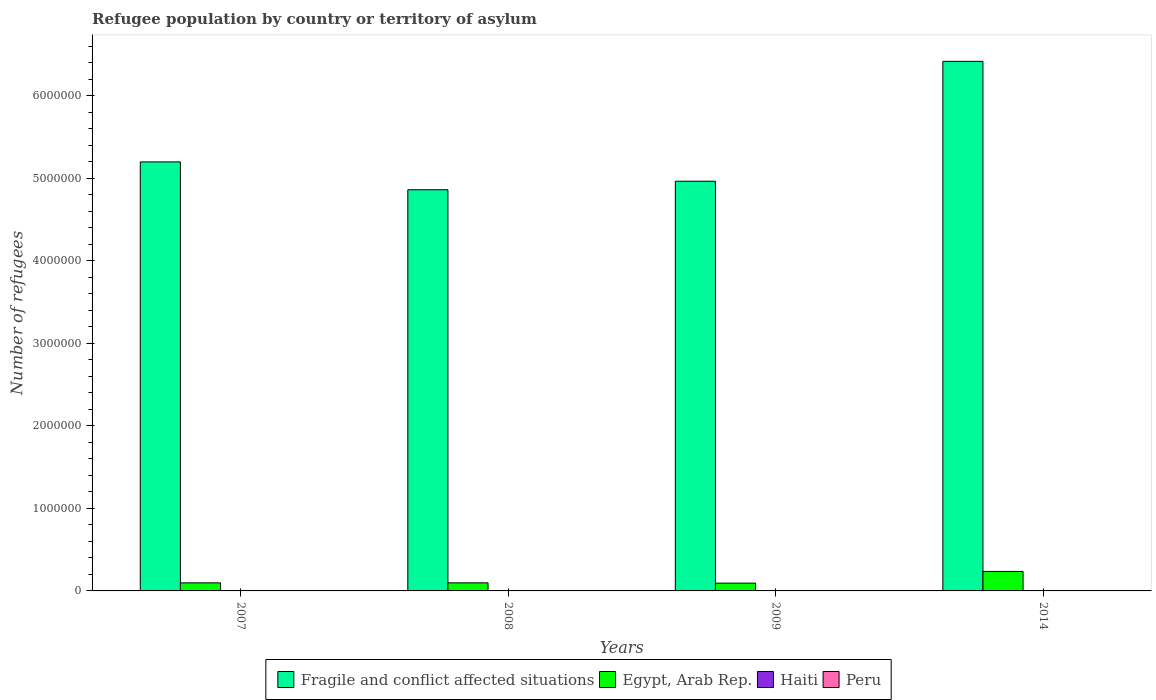How many different coloured bars are there?
Provide a short and direct response. 4. Are the number of bars per tick equal to the number of legend labels?
Make the answer very short. Yes. Are the number of bars on each tick of the X-axis equal?
Make the answer very short. Yes. How many bars are there on the 2nd tick from the left?
Provide a succinct answer. 4. In how many cases, is the number of bars for a given year not equal to the number of legend labels?
Keep it short and to the point. 0. What is the number of refugees in Peru in 2009?
Provide a short and direct response. 1108. Across all years, what is the maximum number of refugees in Egypt, Arab Rep.?
Give a very brief answer. 2.36e+05. Across all years, what is the minimum number of refugees in Fragile and conflict affected situations?
Your answer should be compact. 4.86e+06. In which year was the number of refugees in Egypt, Arab Rep. maximum?
Offer a terse response. 2014. In which year was the number of refugees in Haiti minimum?
Ensure brevity in your answer.  2007. What is the difference between the number of refugees in Egypt, Arab Rep. in 2008 and the number of refugees in Fragile and conflict affected situations in 2009?
Your answer should be compact. -4.87e+06. What is the average number of refugees in Egypt, Arab Rep. per year?
Your answer should be very brief. 1.31e+05. In the year 2014, what is the difference between the number of refugees in Fragile and conflict affected situations and number of refugees in Haiti?
Make the answer very short. 6.42e+06. What is the ratio of the number of refugees in Egypt, Arab Rep. in 2007 to that in 2009?
Offer a terse response. 1.03. What is the difference between the highest and the second highest number of refugees in Fragile and conflict affected situations?
Your answer should be compact. 1.22e+06. What is the difference between the highest and the lowest number of refugees in Egypt, Arab Rep.?
Make the answer very short. 1.42e+05. In how many years, is the number of refugees in Peru greater than the average number of refugees in Peru taken over all years?
Provide a succinct answer. 1. Is the sum of the number of refugees in Haiti in 2009 and 2014 greater than the maximum number of refugees in Fragile and conflict affected situations across all years?
Ensure brevity in your answer.  No. What does the 1st bar from the left in 2008 represents?
Give a very brief answer. Fragile and conflict affected situations. What does the 3rd bar from the right in 2008 represents?
Your answer should be very brief. Egypt, Arab Rep. How many bars are there?
Your answer should be very brief. 16. How many years are there in the graph?
Your answer should be very brief. 4. What is the difference between two consecutive major ticks on the Y-axis?
Your answer should be very brief. 1.00e+06. Are the values on the major ticks of Y-axis written in scientific E-notation?
Your answer should be very brief. No. Does the graph contain grids?
Give a very brief answer. No. Where does the legend appear in the graph?
Offer a very short reply. Bottom center. What is the title of the graph?
Your answer should be compact. Refugee population by country or territory of asylum. Does "South Africa" appear as one of the legend labels in the graph?
Provide a succinct answer. No. What is the label or title of the Y-axis?
Offer a terse response. Number of refugees. What is the Number of refugees of Fragile and conflict affected situations in 2007?
Provide a short and direct response. 5.20e+06. What is the Number of refugees of Egypt, Arab Rep. in 2007?
Your answer should be compact. 9.76e+04. What is the Number of refugees in Peru in 2007?
Offer a very short reply. 995. What is the Number of refugees of Fragile and conflict affected situations in 2008?
Give a very brief answer. 4.86e+06. What is the Number of refugees in Egypt, Arab Rep. in 2008?
Offer a terse response. 9.79e+04. What is the Number of refugees in Haiti in 2008?
Ensure brevity in your answer.  3. What is the Number of refugees of Peru in 2008?
Give a very brief answer. 1075. What is the Number of refugees in Fragile and conflict affected situations in 2009?
Your answer should be compact. 4.96e+06. What is the Number of refugees of Egypt, Arab Rep. in 2009?
Make the answer very short. 9.44e+04. What is the Number of refugees of Haiti in 2009?
Your answer should be compact. 3. What is the Number of refugees in Peru in 2009?
Make the answer very short. 1108. What is the Number of refugees in Fragile and conflict affected situations in 2014?
Keep it short and to the point. 6.42e+06. What is the Number of refugees in Egypt, Arab Rep. in 2014?
Your response must be concise. 2.36e+05. What is the Number of refugees of Peru in 2014?
Offer a very short reply. 1303. Across all years, what is the maximum Number of refugees in Fragile and conflict affected situations?
Your answer should be compact. 6.42e+06. Across all years, what is the maximum Number of refugees in Egypt, Arab Rep.?
Your response must be concise. 2.36e+05. Across all years, what is the maximum Number of refugees in Haiti?
Provide a short and direct response. 3. Across all years, what is the maximum Number of refugees of Peru?
Give a very brief answer. 1303. Across all years, what is the minimum Number of refugees of Fragile and conflict affected situations?
Your response must be concise. 4.86e+06. Across all years, what is the minimum Number of refugees in Egypt, Arab Rep.?
Provide a short and direct response. 9.44e+04. Across all years, what is the minimum Number of refugees of Peru?
Offer a terse response. 995. What is the total Number of refugees in Fragile and conflict affected situations in the graph?
Offer a terse response. 2.14e+07. What is the total Number of refugees of Egypt, Arab Rep. in the graph?
Offer a terse response. 5.26e+05. What is the total Number of refugees of Haiti in the graph?
Offer a terse response. 10. What is the total Number of refugees in Peru in the graph?
Your response must be concise. 4481. What is the difference between the Number of refugees of Fragile and conflict affected situations in 2007 and that in 2008?
Your answer should be very brief. 3.37e+05. What is the difference between the Number of refugees in Egypt, Arab Rep. in 2007 and that in 2008?
Offer a terse response. -305. What is the difference between the Number of refugees of Peru in 2007 and that in 2008?
Provide a succinct answer. -80. What is the difference between the Number of refugees in Fragile and conflict affected situations in 2007 and that in 2009?
Ensure brevity in your answer.  2.34e+05. What is the difference between the Number of refugees in Egypt, Arab Rep. in 2007 and that in 2009?
Offer a terse response. 3150. What is the difference between the Number of refugees in Peru in 2007 and that in 2009?
Give a very brief answer. -113. What is the difference between the Number of refugees in Fragile and conflict affected situations in 2007 and that in 2014?
Keep it short and to the point. -1.22e+06. What is the difference between the Number of refugees in Egypt, Arab Rep. in 2007 and that in 2014?
Keep it short and to the point. -1.39e+05. What is the difference between the Number of refugees in Haiti in 2007 and that in 2014?
Offer a terse response. -2. What is the difference between the Number of refugees in Peru in 2007 and that in 2014?
Offer a terse response. -308. What is the difference between the Number of refugees in Fragile and conflict affected situations in 2008 and that in 2009?
Offer a very short reply. -1.03e+05. What is the difference between the Number of refugees of Egypt, Arab Rep. in 2008 and that in 2009?
Provide a succinct answer. 3455. What is the difference between the Number of refugees of Haiti in 2008 and that in 2009?
Keep it short and to the point. 0. What is the difference between the Number of refugees of Peru in 2008 and that in 2009?
Your answer should be very brief. -33. What is the difference between the Number of refugees in Fragile and conflict affected situations in 2008 and that in 2014?
Ensure brevity in your answer.  -1.56e+06. What is the difference between the Number of refugees of Egypt, Arab Rep. in 2008 and that in 2014?
Your answer should be very brief. -1.38e+05. What is the difference between the Number of refugees of Haiti in 2008 and that in 2014?
Keep it short and to the point. 0. What is the difference between the Number of refugees of Peru in 2008 and that in 2014?
Keep it short and to the point. -228. What is the difference between the Number of refugees of Fragile and conflict affected situations in 2009 and that in 2014?
Provide a succinct answer. -1.45e+06. What is the difference between the Number of refugees of Egypt, Arab Rep. in 2009 and that in 2014?
Make the answer very short. -1.42e+05. What is the difference between the Number of refugees in Haiti in 2009 and that in 2014?
Make the answer very short. 0. What is the difference between the Number of refugees of Peru in 2009 and that in 2014?
Provide a succinct answer. -195. What is the difference between the Number of refugees of Fragile and conflict affected situations in 2007 and the Number of refugees of Egypt, Arab Rep. in 2008?
Offer a very short reply. 5.10e+06. What is the difference between the Number of refugees in Fragile and conflict affected situations in 2007 and the Number of refugees in Haiti in 2008?
Your response must be concise. 5.20e+06. What is the difference between the Number of refugees of Fragile and conflict affected situations in 2007 and the Number of refugees of Peru in 2008?
Your answer should be very brief. 5.20e+06. What is the difference between the Number of refugees in Egypt, Arab Rep. in 2007 and the Number of refugees in Haiti in 2008?
Keep it short and to the point. 9.76e+04. What is the difference between the Number of refugees of Egypt, Arab Rep. in 2007 and the Number of refugees of Peru in 2008?
Ensure brevity in your answer.  9.65e+04. What is the difference between the Number of refugees of Haiti in 2007 and the Number of refugees of Peru in 2008?
Ensure brevity in your answer.  -1074. What is the difference between the Number of refugees of Fragile and conflict affected situations in 2007 and the Number of refugees of Egypt, Arab Rep. in 2009?
Give a very brief answer. 5.10e+06. What is the difference between the Number of refugees in Fragile and conflict affected situations in 2007 and the Number of refugees in Haiti in 2009?
Your answer should be very brief. 5.20e+06. What is the difference between the Number of refugees of Fragile and conflict affected situations in 2007 and the Number of refugees of Peru in 2009?
Make the answer very short. 5.20e+06. What is the difference between the Number of refugees of Egypt, Arab Rep. in 2007 and the Number of refugees of Haiti in 2009?
Offer a terse response. 9.76e+04. What is the difference between the Number of refugees in Egypt, Arab Rep. in 2007 and the Number of refugees in Peru in 2009?
Make the answer very short. 9.64e+04. What is the difference between the Number of refugees of Haiti in 2007 and the Number of refugees of Peru in 2009?
Provide a short and direct response. -1107. What is the difference between the Number of refugees in Fragile and conflict affected situations in 2007 and the Number of refugees in Egypt, Arab Rep. in 2014?
Your answer should be compact. 4.96e+06. What is the difference between the Number of refugees in Fragile and conflict affected situations in 2007 and the Number of refugees in Haiti in 2014?
Your response must be concise. 5.20e+06. What is the difference between the Number of refugees of Fragile and conflict affected situations in 2007 and the Number of refugees of Peru in 2014?
Provide a succinct answer. 5.20e+06. What is the difference between the Number of refugees in Egypt, Arab Rep. in 2007 and the Number of refugees in Haiti in 2014?
Provide a short and direct response. 9.76e+04. What is the difference between the Number of refugees of Egypt, Arab Rep. in 2007 and the Number of refugees of Peru in 2014?
Offer a very short reply. 9.63e+04. What is the difference between the Number of refugees in Haiti in 2007 and the Number of refugees in Peru in 2014?
Provide a succinct answer. -1302. What is the difference between the Number of refugees in Fragile and conflict affected situations in 2008 and the Number of refugees in Egypt, Arab Rep. in 2009?
Keep it short and to the point. 4.77e+06. What is the difference between the Number of refugees of Fragile and conflict affected situations in 2008 and the Number of refugees of Haiti in 2009?
Ensure brevity in your answer.  4.86e+06. What is the difference between the Number of refugees in Fragile and conflict affected situations in 2008 and the Number of refugees in Peru in 2009?
Give a very brief answer. 4.86e+06. What is the difference between the Number of refugees in Egypt, Arab Rep. in 2008 and the Number of refugees in Haiti in 2009?
Offer a terse response. 9.79e+04. What is the difference between the Number of refugees in Egypt, Arab Rep. in 2008 and the Number of refugees in Peru in 2009?
Offer a terse response. 9.68e+04. What is the difference between the Number of refugees of Haiti in 2008 and the Number of refugees of Peru in 2009?
Provide a succinct answer. -1105. What is the difference between the Number of refugees of Fragile and conflict affected situations in 2008 and the Number of refugees of Egypt, Arab Rep. in 2014?
Your answer should be very brief. 4.62e+06. What is the difference between the Number of refugees in Fragile and conflict affected situations in 2008 and the Number of refugees in Haiti in 2014?
Offer a very short reply. 4.86e+06. What is the difference between the Number of refugees of Fragile and conflict affected situations in 2008 and the Number of refugees of Peru in 2014?
Offer a very short reply. 4.86e+06. What is the difference between the Number of refugees of Egypt, Arab Rep. in 2008 and the Number of refugees of Haiti in 2014?
Ensure brevity in your answer.  9.79e+04. What is the difference between the Number of refugees of Egypt, Arab Rep. in 2008 and the Number of refugees of Peru in 2014?
Give a very brief answer. 9.66e+04. What is the difference between the Number of refugees of Haiti in 2008 and the Number of refugees of Peru in 2014?
Offer a very short reply. -1300. What is the difference between the Number of refugees of Fragile and conflict affected situations in 2009 and the Number of refugees of Egypt, Arab Rep. in 2014?
Offer a terse response. 4.73e+06. What is the difference between the Number of refugees in Fragile and conflict affected situations in 2009 and the Number of refugees in Haiti in 2014?
Your response must be concise. 4.96e+06. What is the difference between the Number of refugees in Fragile and conflict affected situations in 2009 and the Number of refugees in Peru in 2014?
Your response must be concise. 4.96e+06. What is the difference between the Number of refugees of Egypt, Arab Rep. in 2009 and the Number of refugees of Haiti in 2014?
Your response must be concise. 9.44e+04. What is the difference between the Number of refugees of Egypt, Arab Rep. in 2009 and the Number of refugees of Peru in 2014?
Offer a terse response. 9.31e+04. What is the difference between the Number of refugees in Haiti in 2009 and the Number of refugees in Peru in 2014?
Keep it short and to the point. -1300. What is the average Number of refugees of Fragile and conflict affected situations per year?
Make the answer very short. 5.36e+06. What is the average Number of refugees of Egypt, Arab Rep. per year?
Offer a terse response. 1.31e+05. What is the average Number of refugees in Haiti per year?
Ensure brevity in your answer.  2.5. What is the average Number of refugees in Peru per year?
Your answer should be very brief. 1120.25. In the year 2007, what is the difference between the Number of refugees of Fragile and conflict affected situations and Number of refugees of Egypt, Arab Rep.?
Keep it short and to the point. 5.10e+06. In the year 2007, what is the difference between the Number of refugees in Fragile and conflict affected situations and Number of refugees in Haiti?
Your answer should be compact. 5.20e+06. In the year 2007, what is the difference between the Number of refugees of Fragile and conflict affected situations and Number of refugees of Peru?
Ensure brevity in your answer.  5.20e+06. In the year 2007, what is the difference between the Number of refugees in Egypt, Arab Rep. and Number of refugees in Haiti?
Offer a terse response. 9.76e+04. In the year 2007, what is the difference between the Number of refugees in Egypt, Arab Rep. and Number of refugees in Peru?
Offer a very short reply. 9.66e+04. In the year 2007, what is the difference between the Number of refugees in Haiti and Number of refugees in Peru?
Your answer should be very brief. -994. In the year 2008, what is the difference between the Number of refugees in Fragile and conflict affected situations and Number of refugees in Egypt, Arab Rep.?
Ensure brevity in your answer.  4.76e+06. In the year 2008, what is the difference between the Number of refugees of Fragile and conflict affected situations and Number of refugees of Haiti?
Give a very brief answer. 4.86e+06. In the year 2008, what is the difference between the Number of refugees of Fragile and conflict affected situations and Number of refugees of Peru?
Offer a very short reply. 4.86e+06. In the year 2008, what is the difference between the Number of refugees of Egypt, Arab Rep. and Number of refugees of Haiti?
Give a very brief answer. 9.79e+04. In the year 2008, what is the difference between the Number of refugees in Egypt, Arab Rep. and Number of refugees in Peru?
Your answer should be compact. 9.68e+04. In the year 2008, what is the difference between the Number of refugees in Haiti and Number of refugees in Peru?
Your answer should be compact. -1072. In the year 2009, what is the difference between the Number of refugees in Fragile and conflict affected situations and Number of refugees in Egypt, Arab Rep.?
Give a very brief answer. 4.87e+06. In the year 2009, what is the difference between the Number of refugees of Fragile and conflict affected situations and Number of refugees of Haiti?
Your answer should be very brief. 4.96e+06. In the year 2009, what is the difference between the Number of refugees of Fragile and conflict affected situations and Number of refugees of Peru?
Provide a short and direct response. 4.96e+06. In the year 2009, what is the difference between the Number of refugees in Egypt, Arab Rep. and Number of refugees in Haiti?
Provide a short and direct response. 9.44e+04. In the year 2009, what is the difference between the Number of refugees in Egypt, Arab Rep. and Number of refugees in Peru?
Your response must be concise. 9.33e+04. In the year 2009, what is the difference between the Number of refugees of Haiti and Number of refugees of Peru?
Offer a very short reply. -1105. In the year 2014, what is the difference between the Number of refugees of Fragile and conflict affected situations and Number of refugees of Egypt, Arab Rep.?
Offer a very short reply. 6.18e+06. In the year 2014, what is the difference between the Number of refugees of Fragile and conflict affected situations and Number of refugees of Haiti?
Make the answer very short. 6.42e+06. In the year 2014, what is the difference between the Number of refugees in Fragile and conflict affected situations and Number of refugees in Peru?
Your response must be concise. 6.41e+06. In the year 2014, what is the difference between the Number of refugees of Egypt, Arab Rep. and Number of refugees of Haiti?
Provide a short and direct response. 2.36e+05. In the year 2014, what is the difference between the Number of refugees of Egypt, Arab Rep. and Number of refugees of Peru?
Provide a short and direct response. 2.35e+05. In the year 2014, what is the difference between the Number of refugees of Haiti and Number of refugees of Peru?
Your answer should be very brief. -1300. What is the ratio of the Number of refugees of Fragile and conflict affected situations in 2007 to that in 2008?
Keep it short and to the point. 1.07. What is the ratio of the Number of refugees in Egypt, Arab Rep. in 2007 to that in 2008?
Your answer should be compact. 1. What is the ratio of the Number of refugees of Haiti in 2007 to that in 2008?
Keep it short and to the point. 0.33. What is the ratio of the Number of refugees in Peru in 2007 to that in 2008?
Give a very brief answer. 0.93. What is the ratio of the Number of refugees in Fragile and conflict affected situations in 2007 to that in 2009?
Provide a succinct answer. 1.05. What is the ratio of the Number of refugees of Egypt, Arab Rep. in 2007 to that in 2009?
Provide a succinct answer. 1.03. What is the ratio of the Number of refugees of Peru in 2007 to that in 2009?
Your response must be concise. 0.9. What is the ratio of the Number of refugees of Fragile and conflict affected situations in 2007 to that in 2014?
Provide a succinct answer. 0.81. What is the ratio of the Number of refugees of Egypt, Arab Rep. in 2007 to that in 2014?
Provide a short and direct response. 0.41. What is the ratio of the Number of refugees of Peru in 2007 to that in 2014?
Your response must be concise. 0.76. What is the ratio of the Number of refugees in Fragile and conflict affected situations in 2008 to that in 2009?
Your answer should be compact. 0.98. What is the ratio of the Number of refugees of Egypt, Arab Rep. in 2008 to that in 2009?
Ensure brevity in your answer.  1.04. What is the ratio of the Number of refugees in Peru in 2008 to that in 2009?
Offer a very short reply. 0.97. What is the ratio of the Number of refugees of Fragile and conflict affected situations in 2008 to that in 2014?
Your answer should be very brief. 0.76. What is the ratio of the Number of refugees of Egypt, Arab Rep. in 2008 to that in 2014?
Offer a terse response. 0.41. What is the ratio of the Number of refugees in Haiti in 2008 to that in 2014?
Your response must be concise. 1. What is the ratio of the Number of refugees of Peru in 2008 to that in 2014?
Provide a short and direct response. 0.82. What is the ratio of the Number of refugees of Fragile and conflict affected situations in 2009 to that in 2014?
Ensure brevity in your answer.  0.77. What is the ratio of the Number of refugees of Egypt, Arab Rep. in 2009 to that in 2014?
Provide a succinct answer. 0.4. What is the ratio of the Number of refugees in Haiti in 2009 to that in 2014?
Your response must be concise. 1. What is the ratio of the Number of refugees in Peru in 2009 to that in 2014?
Give a very brief answer. 0.85. What is the difference between the highest and the second highest Number of refugees of Fragile and conflict affected situations?
Ensure brevity in your answer.  1.22e+06. What is the difference between the highest and the second highest Number of refugees in Egypt, Arab Rep.?
Your answer should be very brief. 1.38e+05. What is the difference between the highest and the second highest Number of refugees of Peru?
Your answer should be very brief. 195. What is the difference between the highest and the lowest Number of refugees of Fragile and conflict affected situations?
Offer a terse response. 1.56e+06. What is the difference between the highest and the lowest Number of refugees of Egypt, Arab Rep.?
Provide a short and direct response. 1.42e+05. What is the difference between the highest and the lowest Number of refugees of Peru?
Your answer should be compact. 308. 